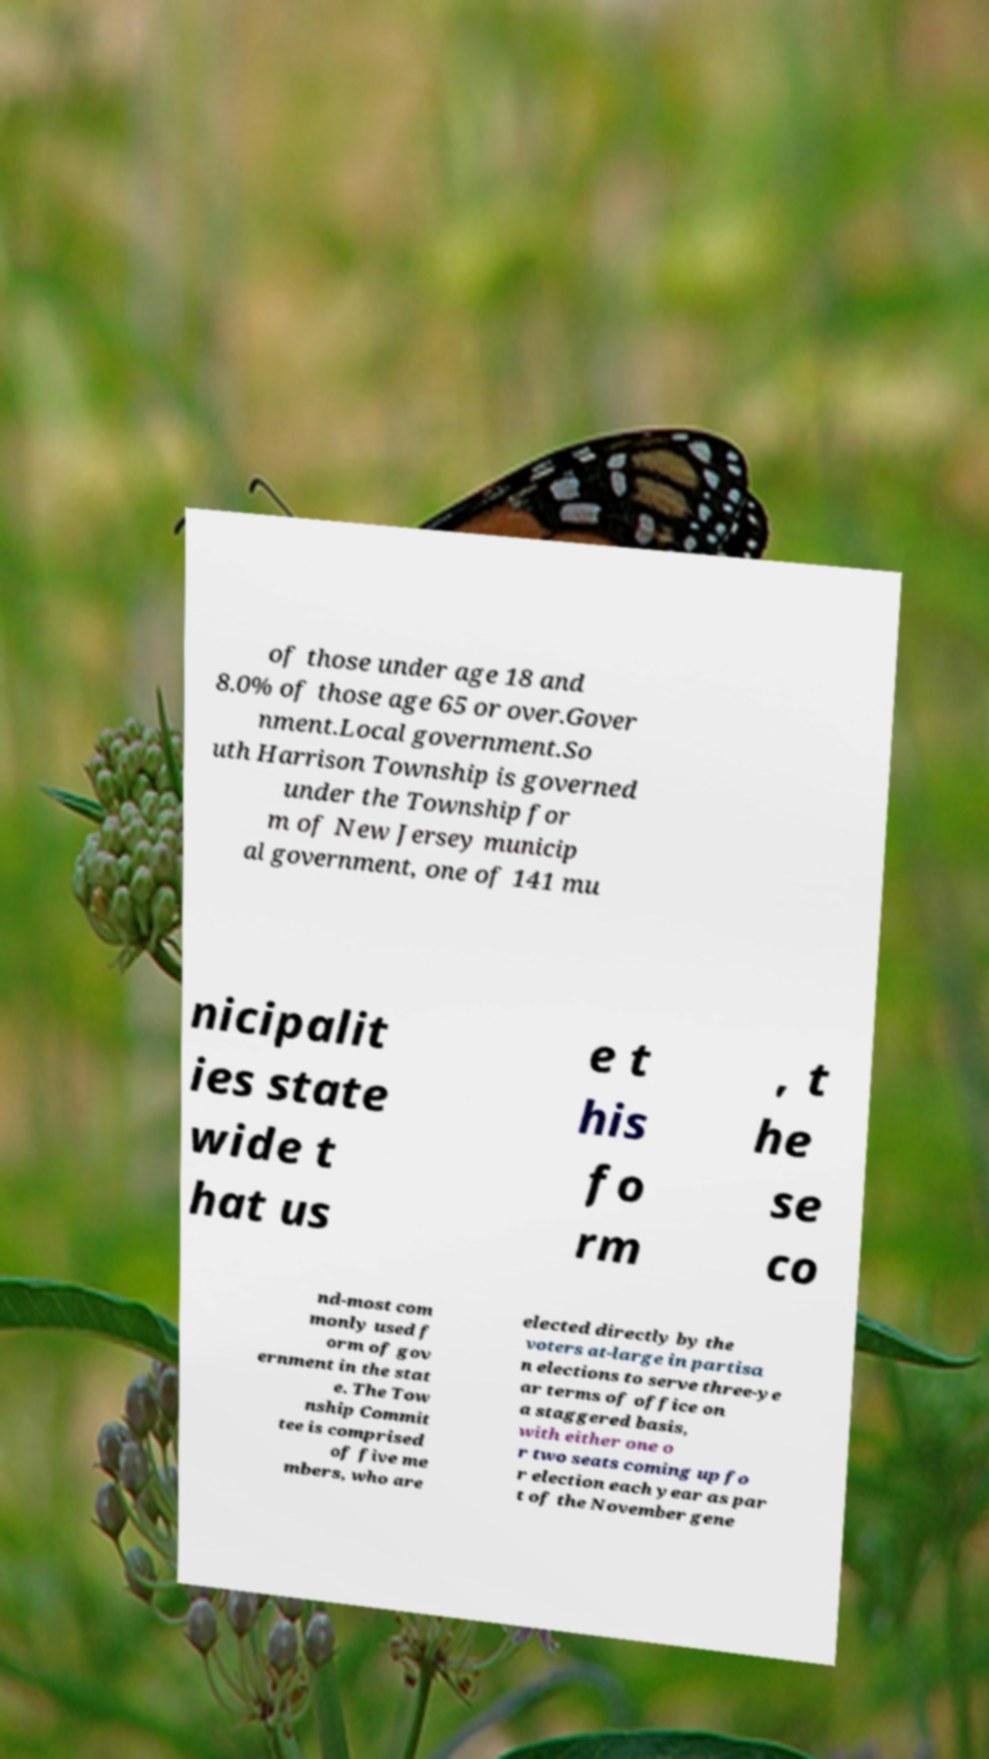Please identify and transcribe the text found in this image. of those under age 18 and 8.0% of those age 65 or over.Gover nment.Local government.So uth Harrison Township is governed under the Township for m of New Jersey municip al government, one of 141 mu nicipalit ies state wide t hat us e t his fo rm , t he se co nd-most com monly used f orm of gov ernment in the stat e. The Tow nship Commit tee is comprised of five me mbers, who are elected directly by the voters at-large in partisa n elections to serve three-ye ar terms of office on a staggered basis, with either one o r two seats coming up fo r election each year as par t of the November gene 